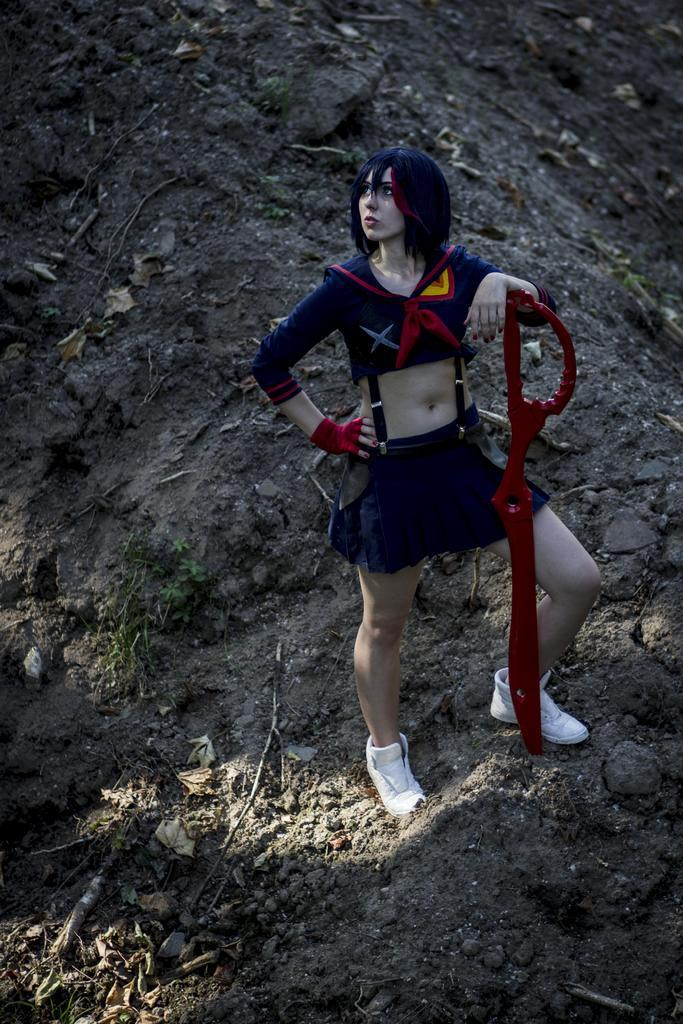Who is the main subject in the image? There is a woman in the image. What is the woman doing in the image? The woman is standing and catching an object with her hand. How many sisters are present in the image? There is no mention of sisters in the image, so it cannot be determined from the image. 